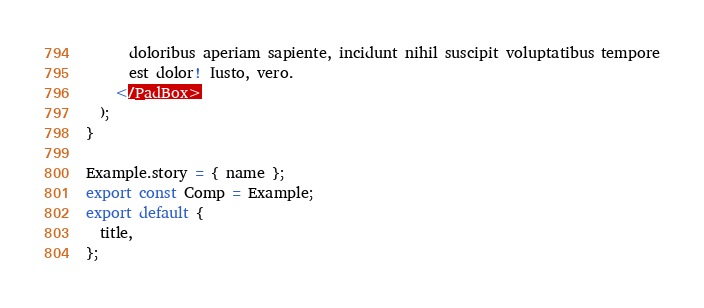Convert code to text. <code><loc_0><loc_0><loc_500><loc_500><_TypeScript_>      doloribus aperiam sapiente, incidunt nihil suscipit voluptatibus tempore
      est dolor! Iusto, vero.
    </PadBox>
  );
}

Example.story = { name };
export const Comp = Example;
export default {
  title,
};
</code> 